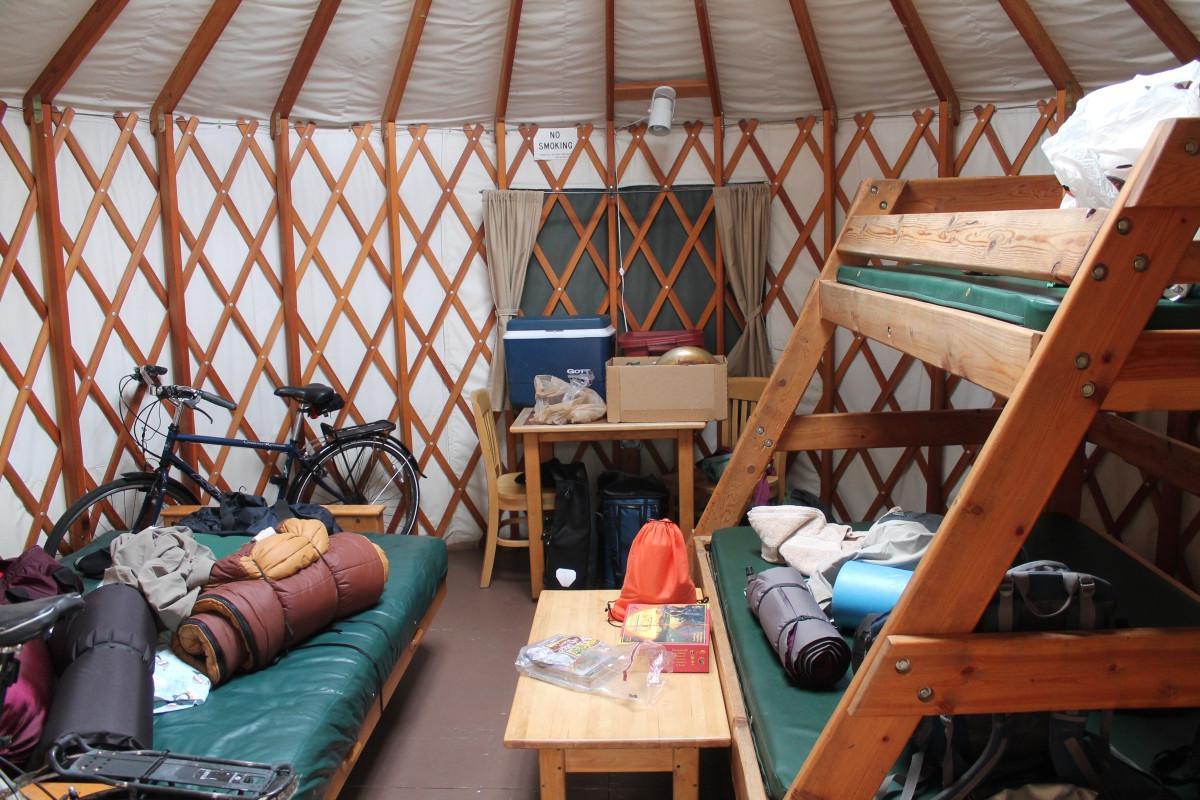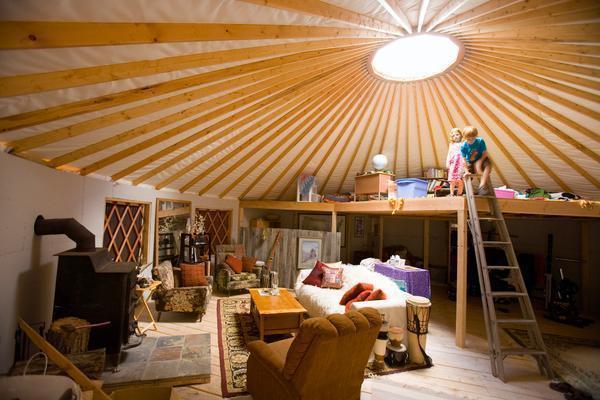The first image is the image on the left, the second image is the image on the right. For the images shown, is this caption "There are at least three chairs around a table located near the windows in one of the images." true? Answer yes or no. No. The first image is the image on the left, the second image is the image on the right. Evaluate the accuracy of this statement regarding the images: "One of the images has a ceiling fixture with at least three lights and the other image has no ceiling lights.". Is it true? Answer yes or no. No. 